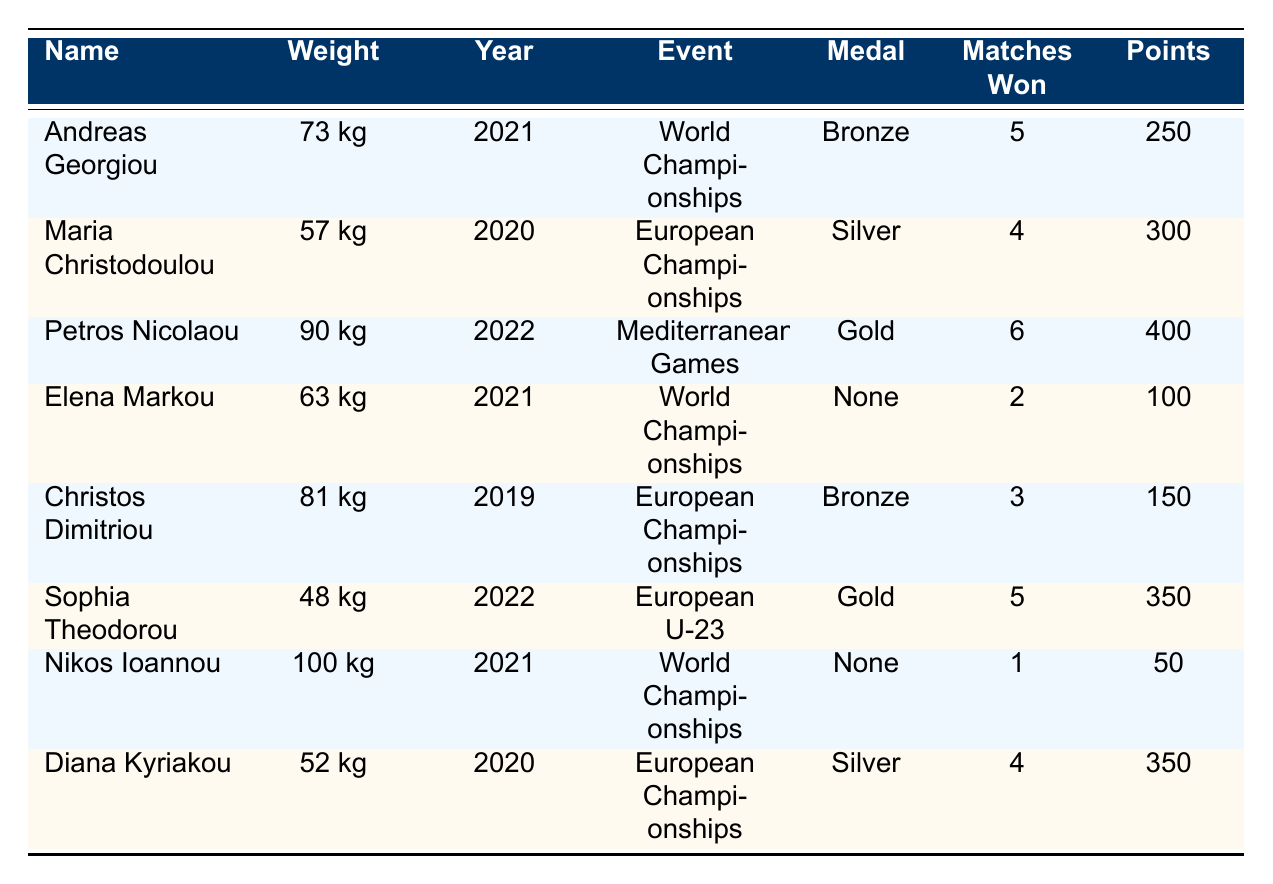What is the name of the athlete who won a gold medal? The table lists the athletes and their respective medals. Petros Nicolaou and Sophia Theodorou are the two athletes who won gold medals.
Answer: Petros Nicolaou and Sophia Theodorou How many matches did Andreas Georgiou win? Looking at Andreas Georgiou's row in the table, the "Matches Won" column shows that he won 5 matches.
Answer: 5 Which athlete had the highest points earned? By comparing the "Points Earned" column, Petros Nicolaou has the highest points of 400, while other athletes have lower scores.
Answer: 400 Did Elena Markou win any medals? The table indicates that Elena Markou's medal is labeled as "None," meaning she did not win a medal.
Answer: No What was the total number of matches won by all athletes in the 2021 World Judo Championships? The athletes in the 2021 World Judo Championships are Andreas Georgiou and Nikos Ioannou. They won 5 and 1 match respectively. So, 5 + 1 = 6.
Answer: 6 Who competed in the 2020 European Judo Championships and what medals did they win? The table shows that Maria Christodoulou and Diana Kyriakou competed in this event, winning Silver medals.
Answer: Maria Christodoulou and Diana Kyriakou both won Silver What is the average number of matches lost by athletes from Cyprus in the Mediterranean Games? The only athlete from Cyprus in the Mediterranean Games is Petros Nicolaou, who has 0 matches lost. Therefore, the average is 0.
Answer: 0 Which weight category had the most wins among the listed athletes? Analyzing the "Matches Won" column across weight categories, Petros Nicolaou (90 kg) and Sophia Theodorou (48 kg) both had 6 and 5 wins respectively. Since 6 is the highest, 90 kg has the most wins.
Answer: 90 kg Was there any athlete who lost all their matches? Referring to the table, there are no athletes listed who lost all their matches; Nikos Ioannou lost 3 matches but won 1.
Answer: No How many points did the athlete with the highest matches won earn? Petros Nicolaou won 6 matches and earned 400 points as per the table.
Answer: 400 What is the difference in points earned between the Silver medalists? Comparing the points, Maria Christodoulou earned 300 points and Diana Kyriakou earned 350 points. The difference is 350 - 300 = 50.
Answer: 50 